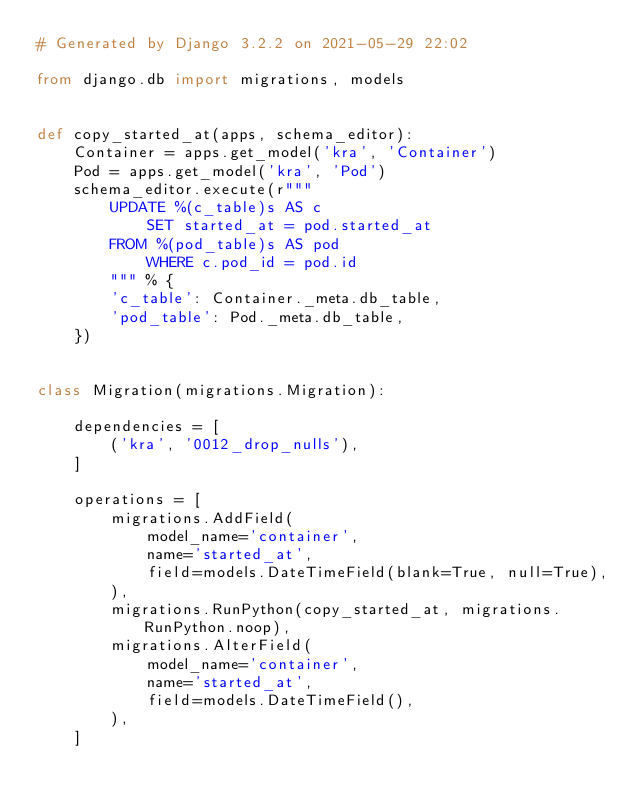Convert code to text. <code><loc_0><loc_0><loc_500><loc_500><_Python_># Generated by Django 3.2.2 on 2021-05-29 22:02

from django.db import migrations, models


def copy_started_at(apps, schema_editor):
    Container = apps.get_model('kra', 'Container')
    Pod = apps.get_model('kra', 'Pod')
    schema_editor.execute(r"""
        UPDATE %(c_table)s AS c
            SET started_at = pod.started_at
        FROM %(pod_table)s AS pod
            WHERE c.pod_id = pod.id
        """ % {
        'c_table': Container._meta.db_table,
        'pod_table': Pod._meta.db_table,
    })


class Migration(migrations.Migration):

    dependencies = [
        ('kra', '0012_drop_nulls'),
    ]

    operations = [
        migrations.AddField(
            model_name='container',
            name='started_at',
            field=models.DateTimeField(blank=True, null=True),
        ),
        migrations.RunPython(copy_started_at, migrations.RunPython.noop),
        migrations.AlterField(
            model_name='container',
            name='started_at',
            field=models.DateTimeField(),
        ),
    ]
</code> 